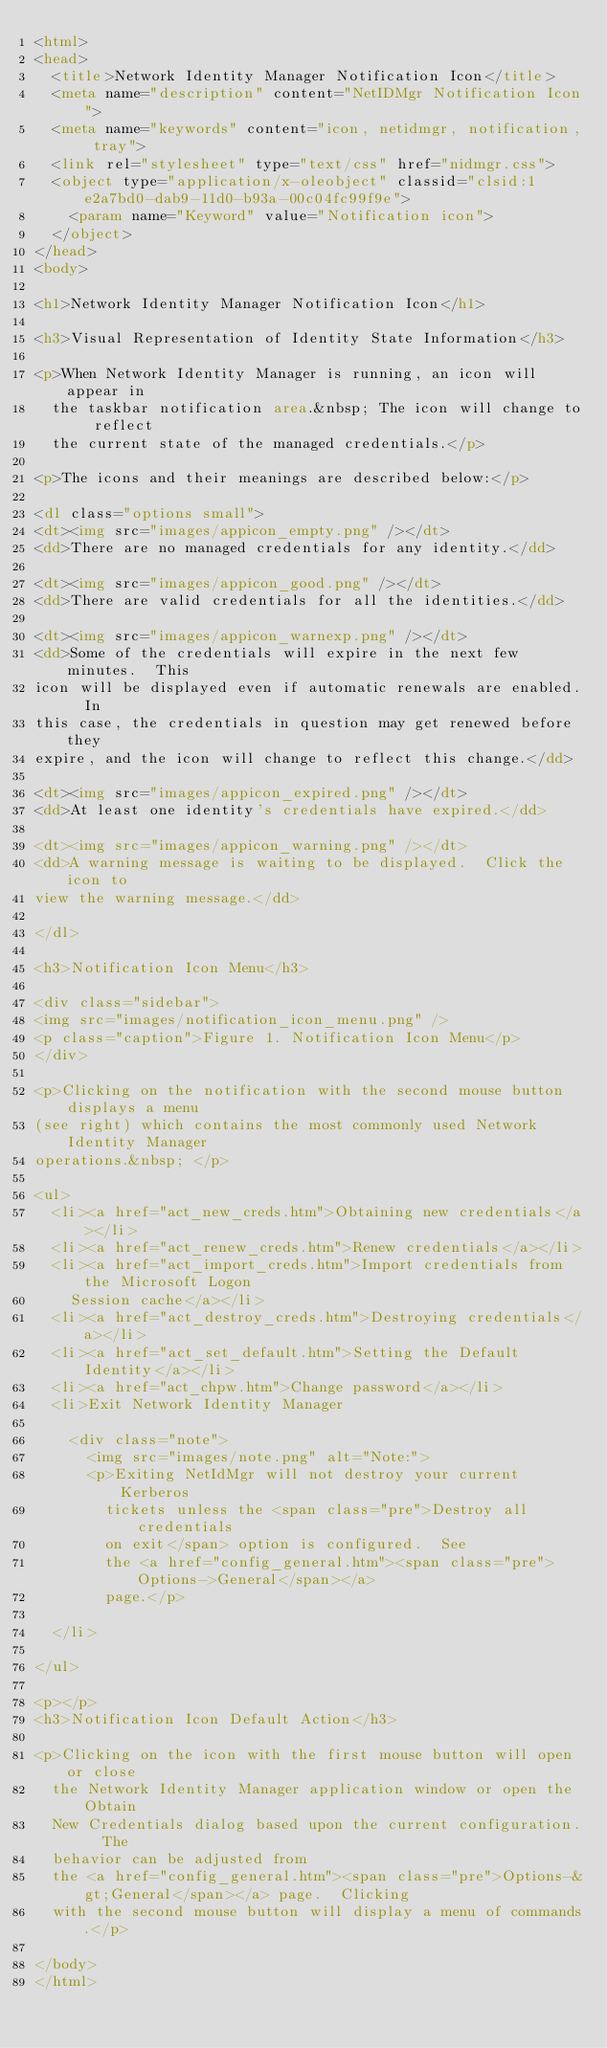<code> <loc_0><loc_0><loc_500><loc_500><_HTML_><html>
<head>
  <title>Network Identity Manager Notification Icon</title>
  <meta name="description" content="NetIDMgr Notification Icon">
  <meta name="keywords" content="icon, netidmgr, notification, tray">
  <link rel="stylesheet" type="text/css" href="nidmgr.css">
  <object type="application/x-oleobject" classid="clsid:1e2a7bd0-dab9-11d0-b93a-00c04fc99f9e">
    <param name="Keyword" value="Notification icon">
  </object>
</head>
<body>

<h1>Network Identity Manager Notification Icon</h1>

<h3>Visual Representation of Identity State Information</h3>

<p>When Network Identity Manager is running, an icon will appear in
  the taskbar notification area.&nbsp; The icon will change to reflect
  the current state of the managed credentials.</p>

<p>The icons and their meanings are described below:</p>

<dl class="options small">
<dt><img src="images/appicon_empty.png" /></dt>
<dd>There are no managed credentials for any identity.</dd>

<dt><img src="images/appicon_good.png" /></dt>
<dd>There are valid credentials for all the identities.</dd>

<dt><img src="images/appicon_warnexp.png" /></dt>
<dd>Some of the credentials will expire in the next few minutes.  This
icon will be displayed even if automatic renewals are enabled.  In
this case, the credentials in question may get renewed before they
expire, and the icon will change to reflect this change.</dd>

<dt><img src="images/appicon_expired.png" /></dt>
<dd>At least one identity's credentials have expired.</dd>

<dt><img src="images/appicon_warning.png" /></dt>
<dd>A warning message is waiting to be displayed.  Click the icon to
view the warning message.</dd>

</dl>

<h3>Notification Icon Menu</h3>

<div class="sidebar">
<img src="images/notification_icon_menu.png" />
<p class="caption">Figure 1. Notification Icon Menu</p>
</div>

<p>Clicking on the notification with the second mouse button displays a menu
(see right) which contains the most commonly used Network Identity Manager
operations.&nbsp; </p>

<ul>
  <li><a href="act_new_creds.htm">Obtaining new credentials</a></li>
  <li><a href="act_renew_creds.htm">Renew credentials</a></li>
  <li><a href="act_import_creds.htm">Import credentials from the Microsoft Logon
	Session cache</a></li>
  <li><a href="act_destroy_creds.htm">Destroying credentials</a></li>
  <li><a href="act_set_default.htm">Setting the Default Identity</a></li>
  <li><a href="act_chpw.htm">Change password</a></li>
  <li>Exit Network Identity Manager

    <div class="note">
      <img src="images/note.png" alt="Note:">
      <p>Exiting NetIdMgr will not destroy your current Kerberos
        tickets unless the <span class="pre">Destroy all credentials
        on exit</span> option is configured.  See
        the <a href="config_general.htm"><span class="pre">Options->General</span></a>
        page.</p>

  </li>

</ul>

<p></p>
<h3>Notification Icon Default Action</h3>

<p>Clicking on the icon with the first mouse button will open or close
  the Network Identity Manager application window or open the Obtain
  New Credentials dialog based upon the current configuration.  The
  behavior can be adjusted from
  the <a href="config_general.htm"><span class="pre">Options-&gt;General</span></a> page.  Clicking
  with the second mouse button will display a menu of commands.</p>

</body>
</html>
</code> 